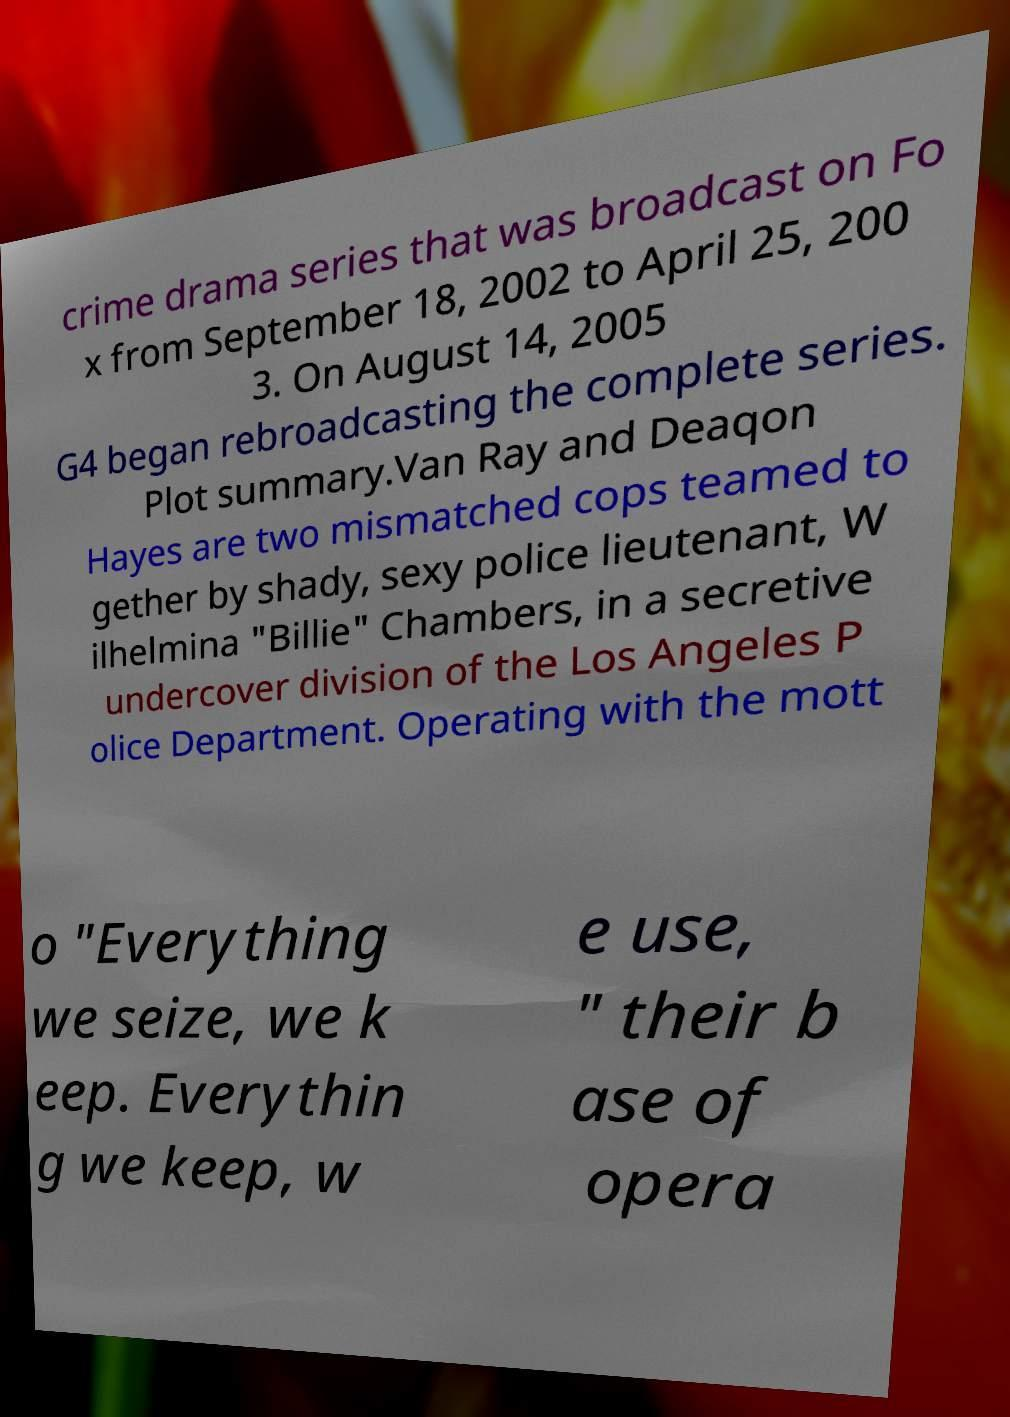There's text embedded in this image that I need extracted. Can you transcribe it verbatim? crime drama series that was broadcast on Fo x from September 18, 2002 to April 25, 200 3. On August 14, 2005 G4 began rebroadcasting the complete series. Plot summary.Van Ray and Deaqon Hayes are two mismatched cops teamed to gether by shady, sexy police lieutenant, W ilhelmina "Billie" Chambers, in a secretive undercover division of the Los Angeles P olice Department. Operating with the mott o "Everything we seize, we k eep. Everythin g we keep, w e use, " their b ase of opera 